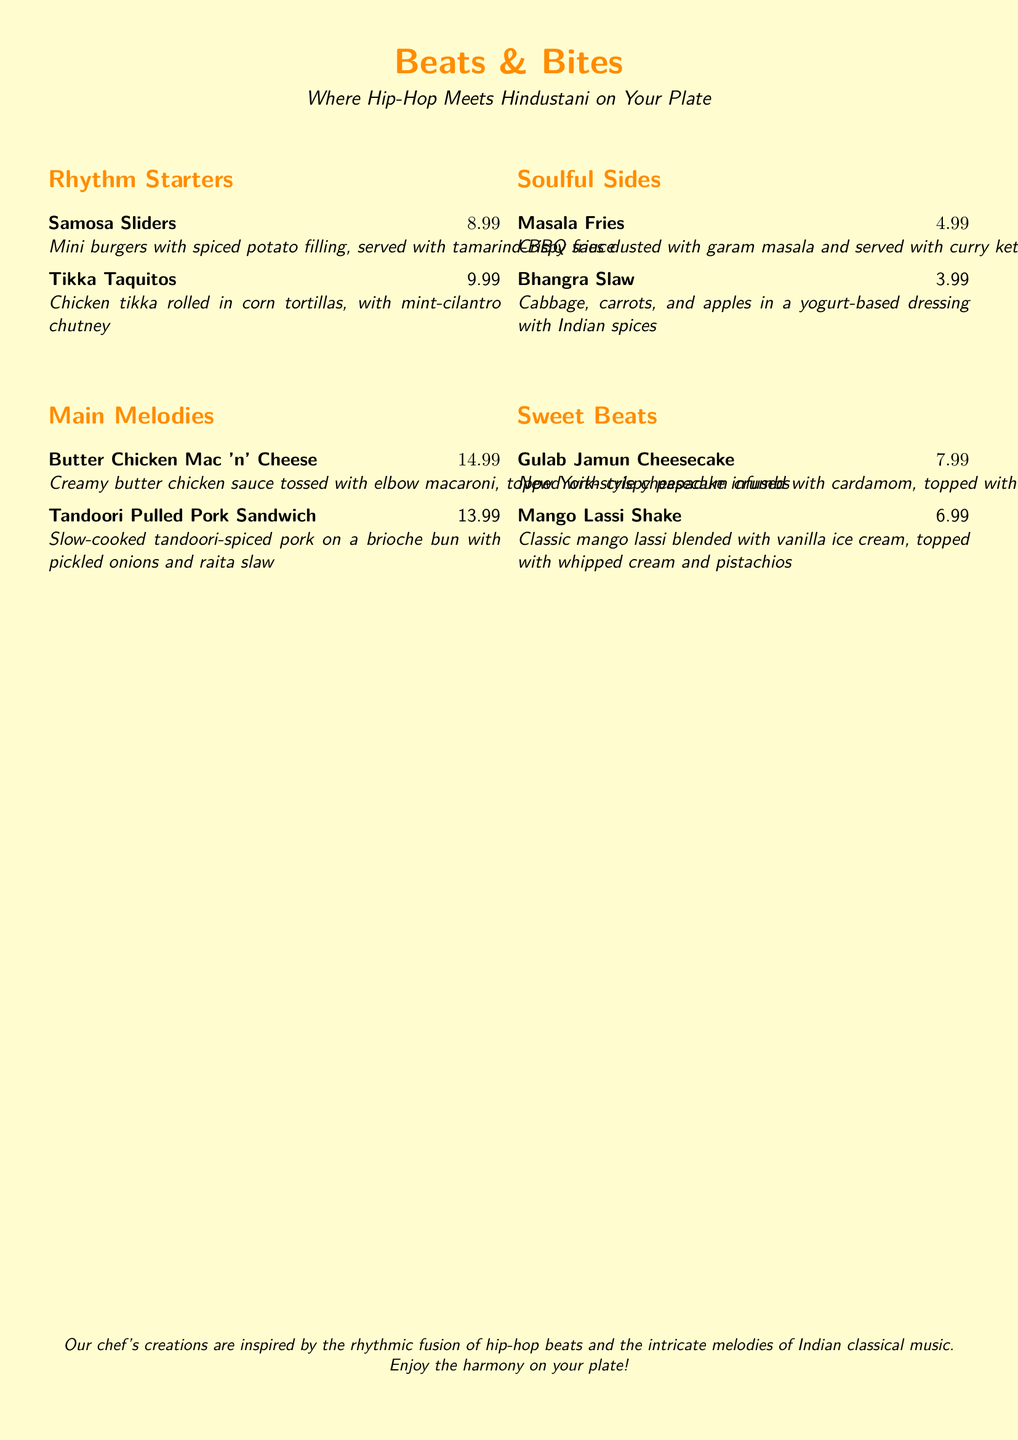What is the name of the restaurant? The restaurant is called "Beats & Bites," as stated in the document's title.
Answer: Beats & Bites How much do the Samosa Sliders cost? The price of the Samosa Sliders is listed next to the item, which is $8.99.
Answer: $8.99 What type of cuisine is featured on the menu? The menu combines elements of American and Indian flavors, as described in the introduction.
Answer: American and Indian What is unique about the Butter Chicken Mac 'n' Cheese? It is described as creamy butter chicken sauce tossed with elbow macaroni, making it a unique fusion dish.
Answer: Fusion dish What are the ingredients in the Bhangra Slaw? The ingredients listed are cabbage, carrots, apples, and a yogurt-based dressing with Indian spices.
Answer: Cabbage, carrots, apples How many items are listed under Soulful Sides? The document lists two items under Soulful Sides, those being Masala Fries and Bhangra Slaw.
Answer: Two items What dessert is made with gulab jamun? The dessert that features gulab jamun is the Gulab Jamun Cheesecake.
Answer: Gulab Jamun Cheesecake Which drink is a blend of classic mango lassi and vanilla ice cream? The drink combining these elements is called the Mango Lassi Shake, as indicated on the menu.
Answer: Mango Lassi Shake What illustration style is used in the menu? The menu is presented on a graffiti-style background, which is prominently mentioned in the description.
Answer: Graffiti-style 